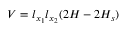<formula> <loc_0><loc_0><loc_500><loc_500>V = l _ { x _ { 1 } } l _ { x _ { 2 } } ( 2 H - 2 H _ { s } )</formula> 